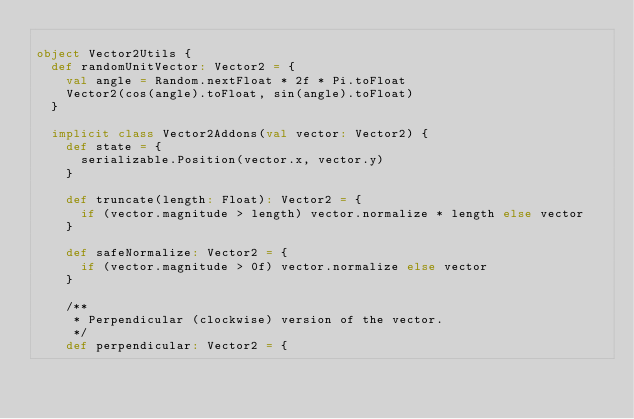<code> <loc_0><loc_0><loc_500><loc_500><_Scala_>
object Vector2Utils {
  def randomUnitVector: Vector2 = {
    val angle = Random.nextFloat * 2f * Pi.toFloat
    Vector2(cos(angle).toFloat, sin(angle).toFloat)
  }

  implicit class Vector2Addons(val vector: Vector2) {
    def state = {
      serializable.Position(vector.x, vector.y)
    }
    
    def truncate(length: Float): Vector2 = {
      if (vector.magnitude > length) vector.normalize * length else vector
    }

    def safeNormalize: Vector2 = {
      if (vector.magnitude > 0f) vector.normalize else vector
    }

    /**
     * Perpendicular (clockwise) version of the vector.
     */
    def perpendicular: Vector2 = {</code> 